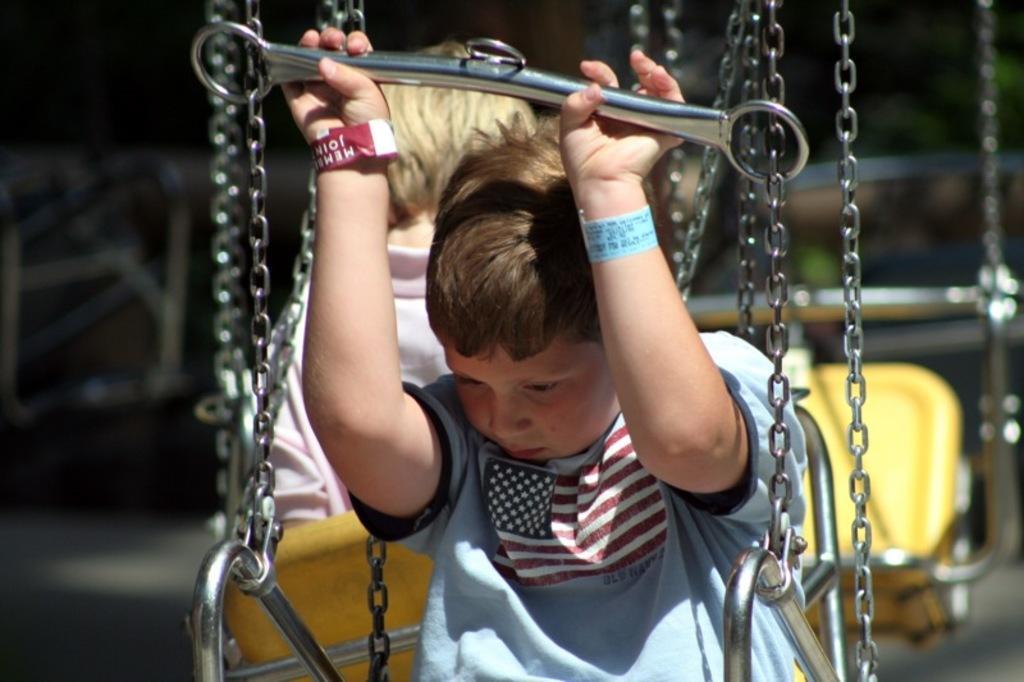Could you give a brief overview of what you see in this image? In this image there are two boys sitting on the swings. Behind them there is another swing. The background is blurry. 